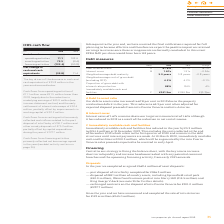Comparing values in Intu Properties's report, What is debt to assets ratio in 2019? According to the financial document, 67.8 (percentage). The relevant text states: "Notes 2019 2018 Change Debt to assets ratio A 67.8% 53.1% 14.7% Interest cover B 1.67x 1.91x –0.24x Weighted average debt maturity 5.0 years 5.8 years..." Also, What is the weighted average debt maturity in 2019? According to the financial document, 5.0 years. The relevant text states: "1.67x 1.91x –0.24x Weighted average debt maturity 5.0 years 5.8 years –0.8 years Weighted average cost of gross debt (excluding RCF) 4.3% 4.2% –0.1% Proportion..." Also, What is the weighted average cost of gross debt (excluding RCF) in 2019? According to the financial document, 4.3 (percentage). The relevant text states: "ighted average cost of gross debt (excluding RCF) 4.3% 4.2% –0.1% Proportion of gross debt with interest rate protection 88% 84% 4% Immediately available..." Also, can you calculate: What is the percentage change in the immediately available cash and facilities from 2018 to 2019? Based on the calculation: (5.3)/246.8, the result is -2.15 (percentage). This is based on the information: "ediately available cash and facilities C £241.5m £246.8m £(5.3)m available cash and facilities C £241.5m £246.8m £(5.3)m..." The key data points involved are: 246.8, 5.3. Also, can you calculate: What is the change in the proportion of gross debt with interest rate protection from 2018 to 2019? Based on the calculation: 88-84, the result is 4 (percentage). This is based on the information: "n of gross debt with interest rate protection 88% 84% 4% Immediately available cash and facilities C £241.5m £246.8m £(5.3)m rtion of gross debt with interest rate protection 88% 84% 4% Immediately av..." The key data points involved are: 84, 88. Also, can you calculate: What is the change in the debt to assets ration from 2018 to 2019 when it is adjusted for expected disposal proceeds from intu Puerto Venecia and intu Asturias? Based on the calculation: 65.3-53.1, the result is 12.2 (percentage). This is based on the information: "tes 2019 2018 Change Debt to assets ratio A 67.8% 53.1% 14.7% Interest cover B 1.67x 1.91x –0.24x Weighted average debt maturity 5.0 years 5.8 years –0.8 revaluation deficit in the year. This reduces ..." The key data points involved are: 53.1, 65.3. 